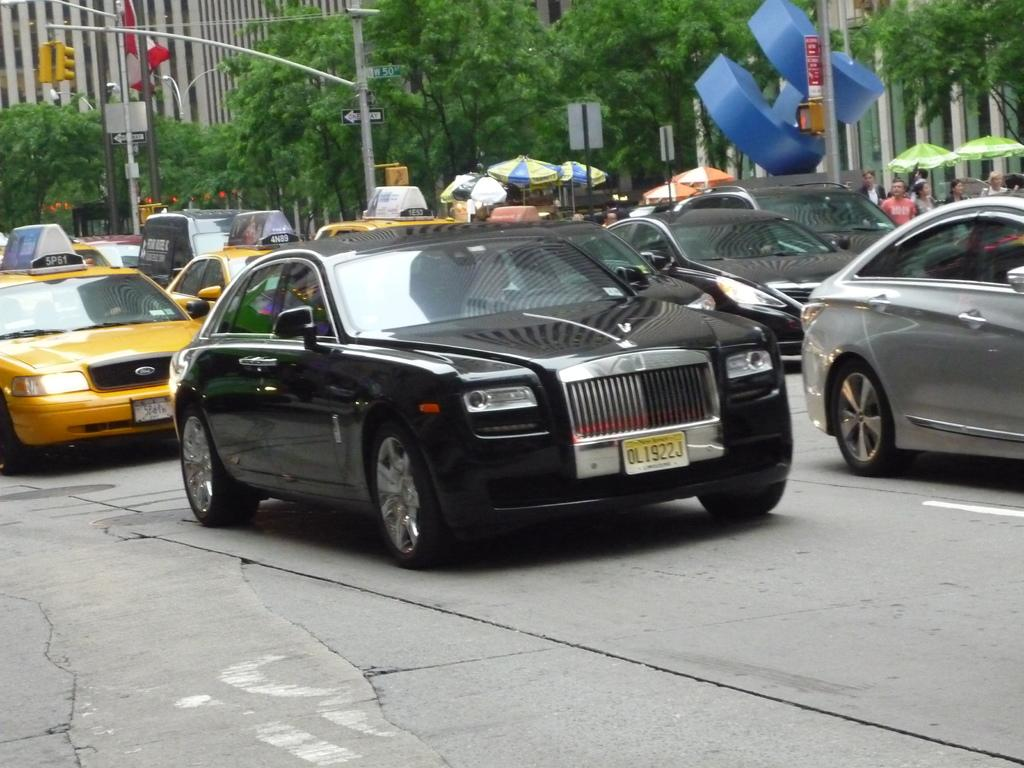<image>
Offer a succinct explanation of the picture presented. A black car with license plate number 0L1922J is in traffic. 